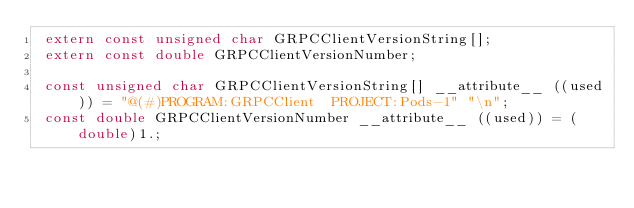Convert code to text. <code><loc_0><loc_0><loc_500><loc_500><_C_> extern const unsigned char GRPCClientVersionString[];
 extern const double GRPCClientVersionNumber;

 const unsigned char GRPCClientVersionString[] __attribute__ ((used)) = "@(#)PROGRAM:GRPCClient  PROJECT:Pods-1" "\n";
 const double GRPCClientVersionNumber __attribute__ ((used)) = (double)1.;
</code> 